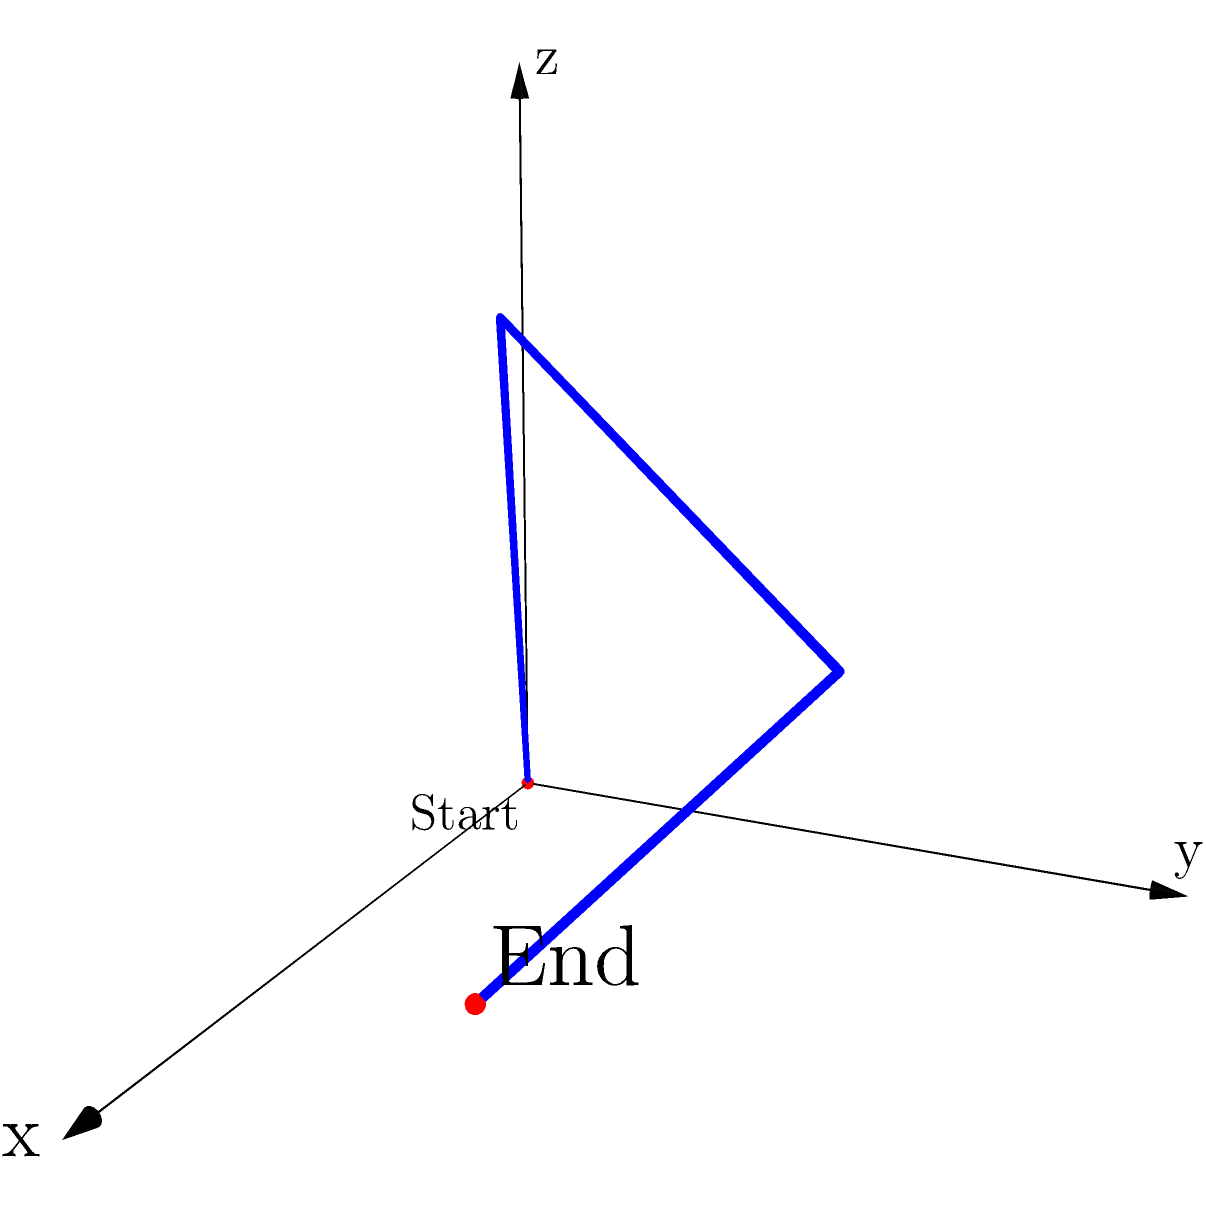Given the 3D coordinate system representing latitude (x), longitude (y), and altitude (z) in arbitrary units, a flight path for an aeromedical evacuation is shown. The flight starts at (0,0,0) and ends at (4,2,1), passing through two intermediate points. What is the total change in altitude from the start to the end of this evacuation flight? To find the change in altitude, we need to focus on the z-coordinates of the start and end points:

1. Start point: (0,0,0)
   The z-coordinate (altitude) at the start is 0.

2. End point: (4,2,1)
   The z-coordinate (altitude) at the end is 1.

3. Calculate the change in altitude:
   $\Delta z = z_{end} - z_{start}$
   $\Delta z = 1 - 0 = 1$

The change in altitude is positive, indicating a net gain in altitude from the start to the end of the flight.

Note: The intermediate points (2,1,3) and (3,3,2) are not relevant for calculating the overall change in altitude, as we are only concerned with the net change from start to end.
Answer: 1 unit 